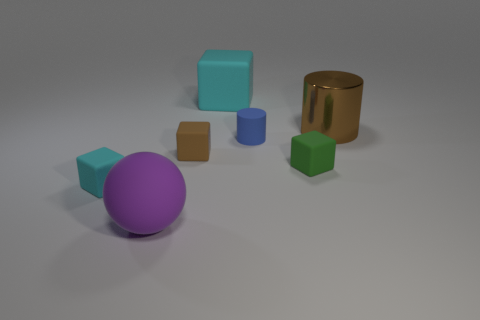How would you describe the lighting in the scene? The lighting appears to be soft and diffused, coming from an overhead source. It casts gentle shadows on the ground, indicating the light is not highly directional. 